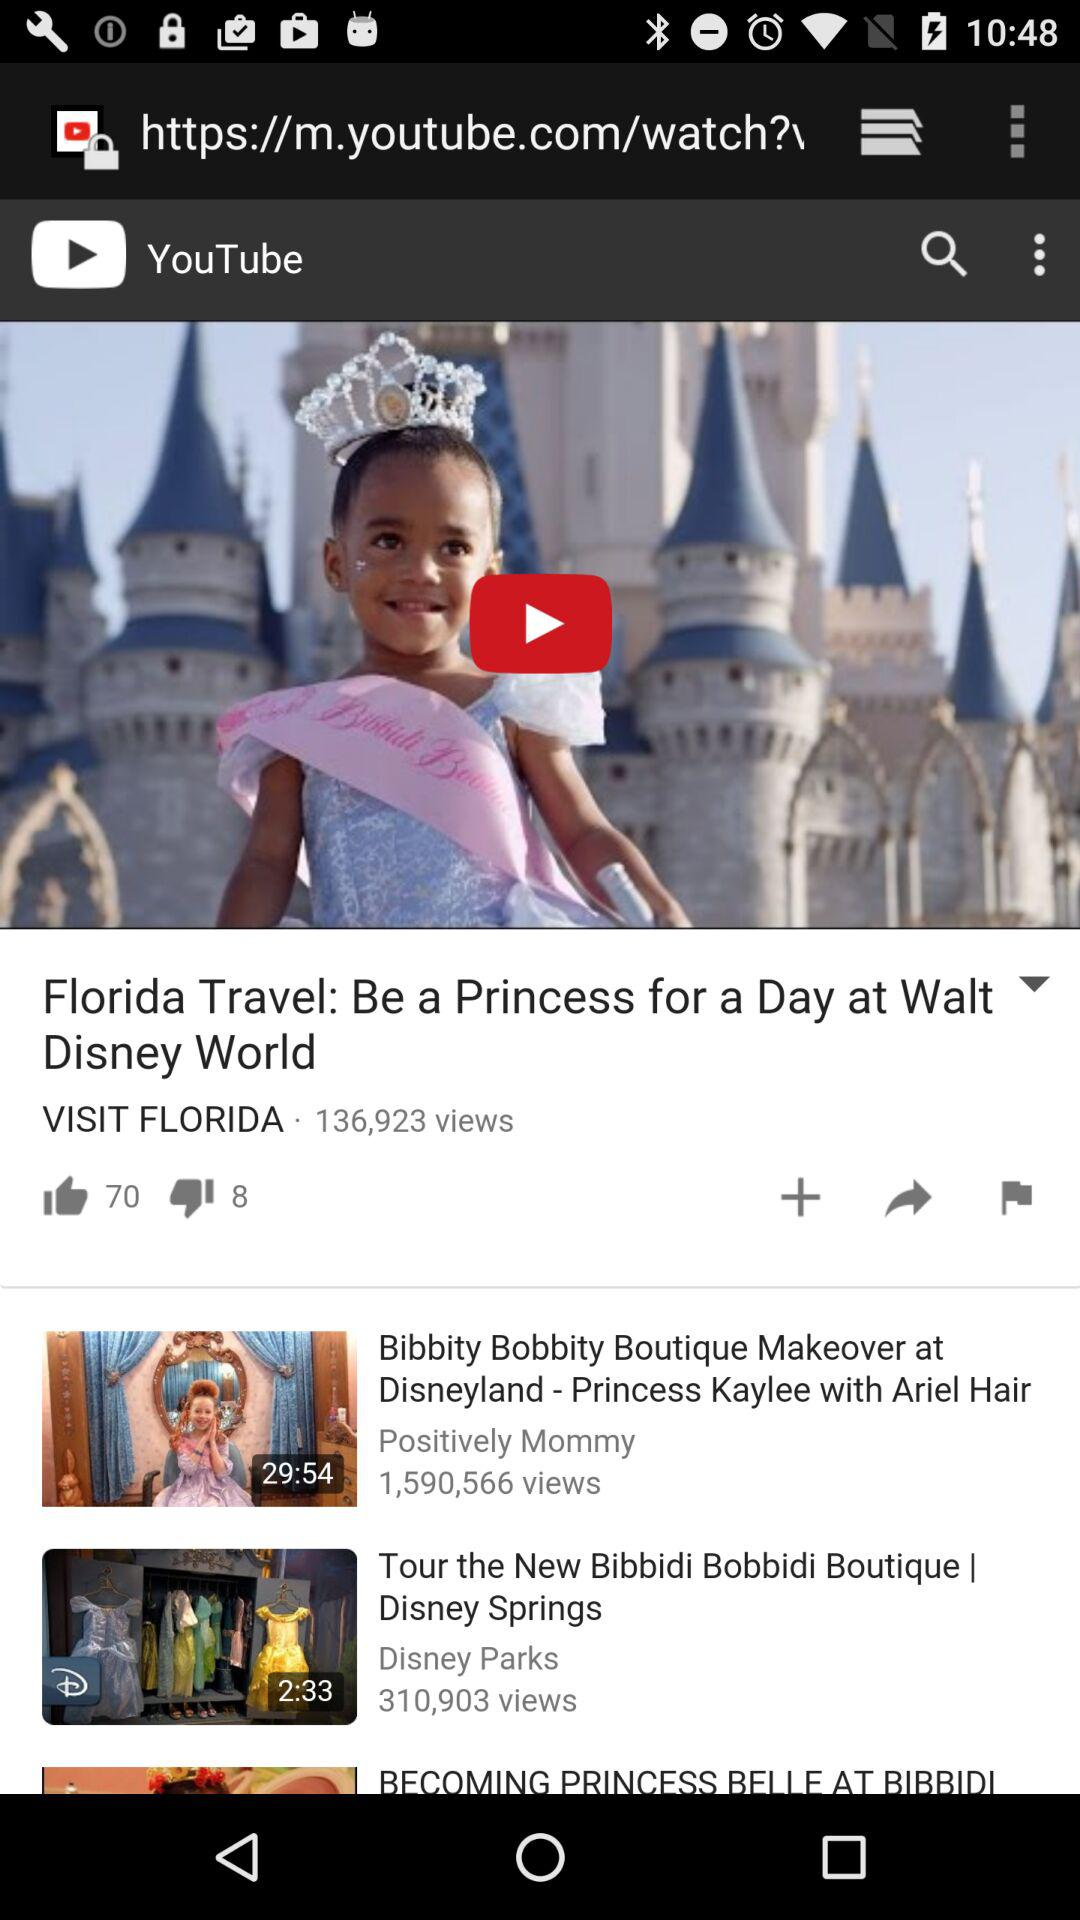How many dislikes did the video "Florida Travel" get? The video "Florida Travel" got 8 dislikes. 